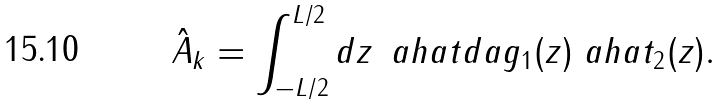<formula> <loc_0><loc_0><loc_500><loc_500>\hat { A } _ { k } = \int _ { - L / 2 } ^ { L / 2 } d z \, \ a h a t d a g _ { 1 } ( z ) \ a h a t _ { 2 } ( z ) .</formula> 